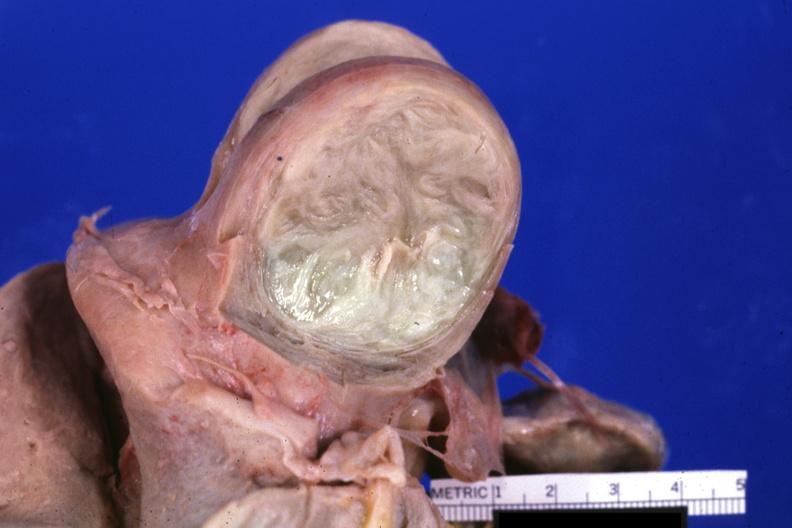s leiomyoma present?
Answer the question using a single word or phrase. Yes 